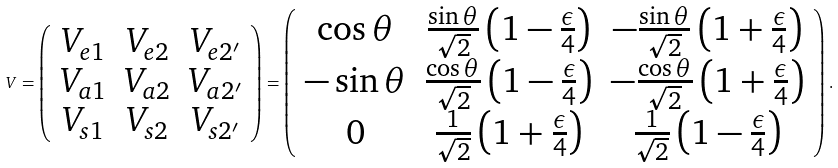Convert formula to latex. <formula><loc_0><loc_0><loc_500><loc_500>V = \left ( \begin{array} { c c c } V _ { e 1 } & V _ { e 2 } & V _ { e 2 ^ { \prime } } \\ V _ { a 1 } & V _ { a 2 } & V _ { a 2 ^ { \prime } } \\ V _ { s 1 } & V _ { s 2 } & V _ { s 2 ^ { \prime } } \end{array} \right ) = \left ( \begin{array} { c c c } \cos \theta & \frac { \sin \theta } { \sqrt { 2 } } \left ( 1 - \frac { \epsilon } { 4 } \right ) & - \frac { \sin \theta } { \sqrt { 2 } } \left ( 1 + \frac { \epsilon } { 4 } \right ) \\ - \sin \theta & \frac { \cos \theta } { \sqrt { 2 } } \left ( 1 - \frac { \epsilon } { 4 } \right ) & - \frac { \cos \theta } { \sqrt { 2 } } \left ( 1 + \frac { \epsilon } { 4 } \right ) \\ 0 & \frac { 1 } { \sqrt { 2 } } \left ( 1 + \frac { \epsilon } { 4 } \right ) & \frac { 1 } { \sqrt { 2 } } \left ( 1 - \frac { \epsilon } { 4 } \right ) \end{array} \right ) .</formula> 